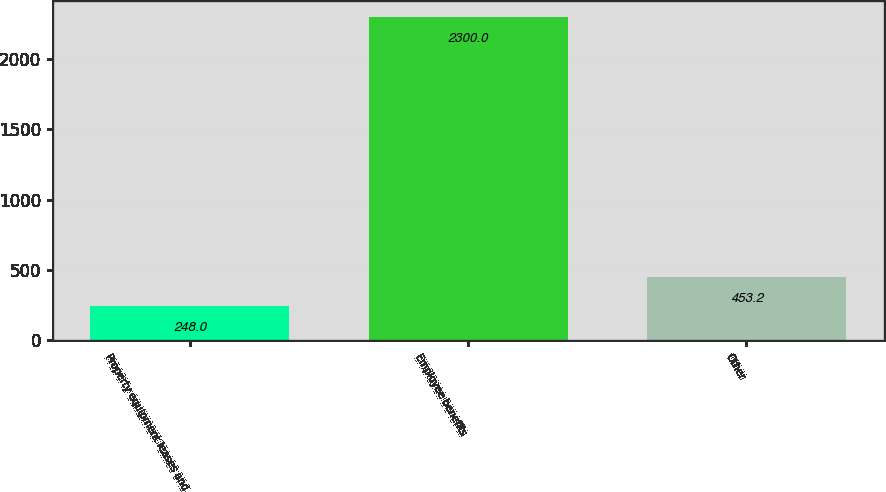<chart> <loc_0><loc_0><loc_500><loc_500><bar_chart><fcel>Property equipment leases and<fcel>Employee benefits<fcel>Other<nl><fcel>248<fcel>2300<fcel>453.2<nl></chart> 